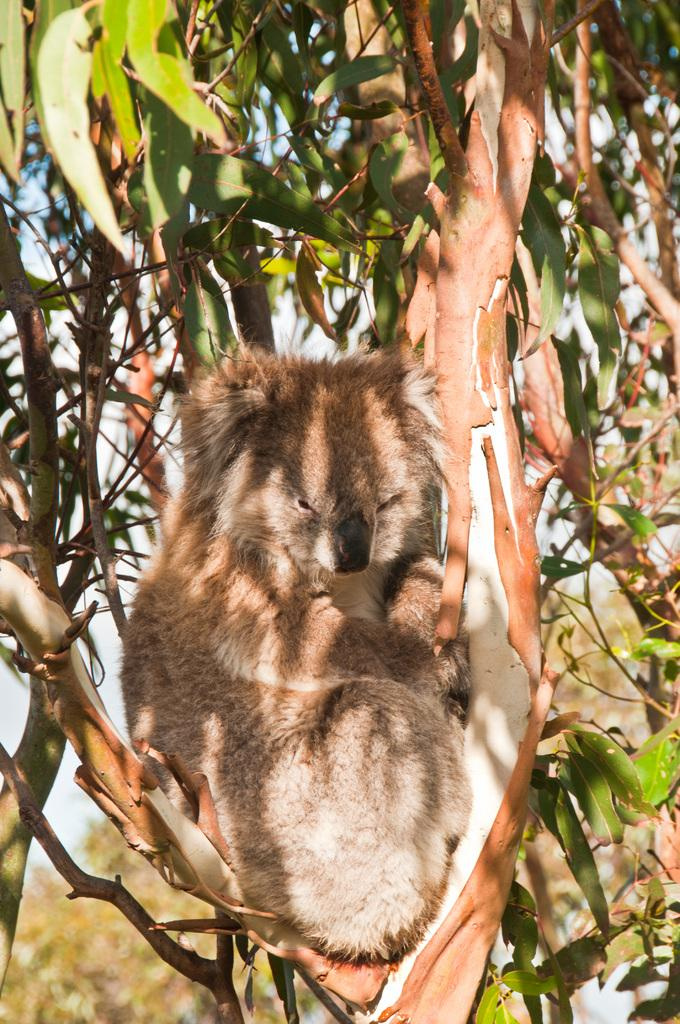What type of animal can be seen in the image? There is an animal in the image, but its specific type cannot be determined from the provided facts. Where is the animal located in the image? The animal is sitting on a tree in the image. What can be seen in the background of the image? There are trees visible in the background of the image. What is the animal's desire for the nearby hill in the image? There is no hill present in the image, and therefore no such desire can be attributed to the animal. 